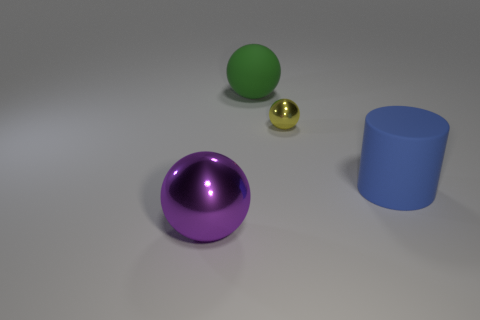Subtract all cylinders. How many objects are left? 3 Add 3 tiny yellow things. How many objects exist? 7 Add 4 blue matte cylinders. How many blue matte cylinders are left? 5 Add 2 tiny yellow rubber objects. How many tiny yellow rubber objects exist? 2 Subtract 1 yellow balls. How many objects are left? 3 Subtract all big purple shiny objects. Subtract all green balls. How many objects are left? 2 